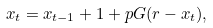Convert formula to latex. <formula><loc_0><loc_0><loc_500><loc_500>x _ { t } = x _ { t - 1 } + 1 + p G ( r - x _ { t } ) ,</formula> 